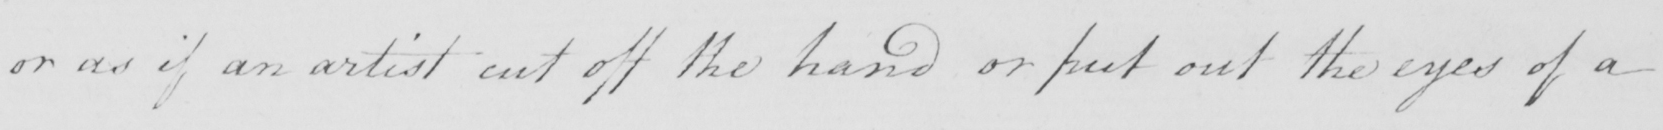Please provide the text content of this handwritten line. or as if an artist cut off the hand or put out the eyes of a 